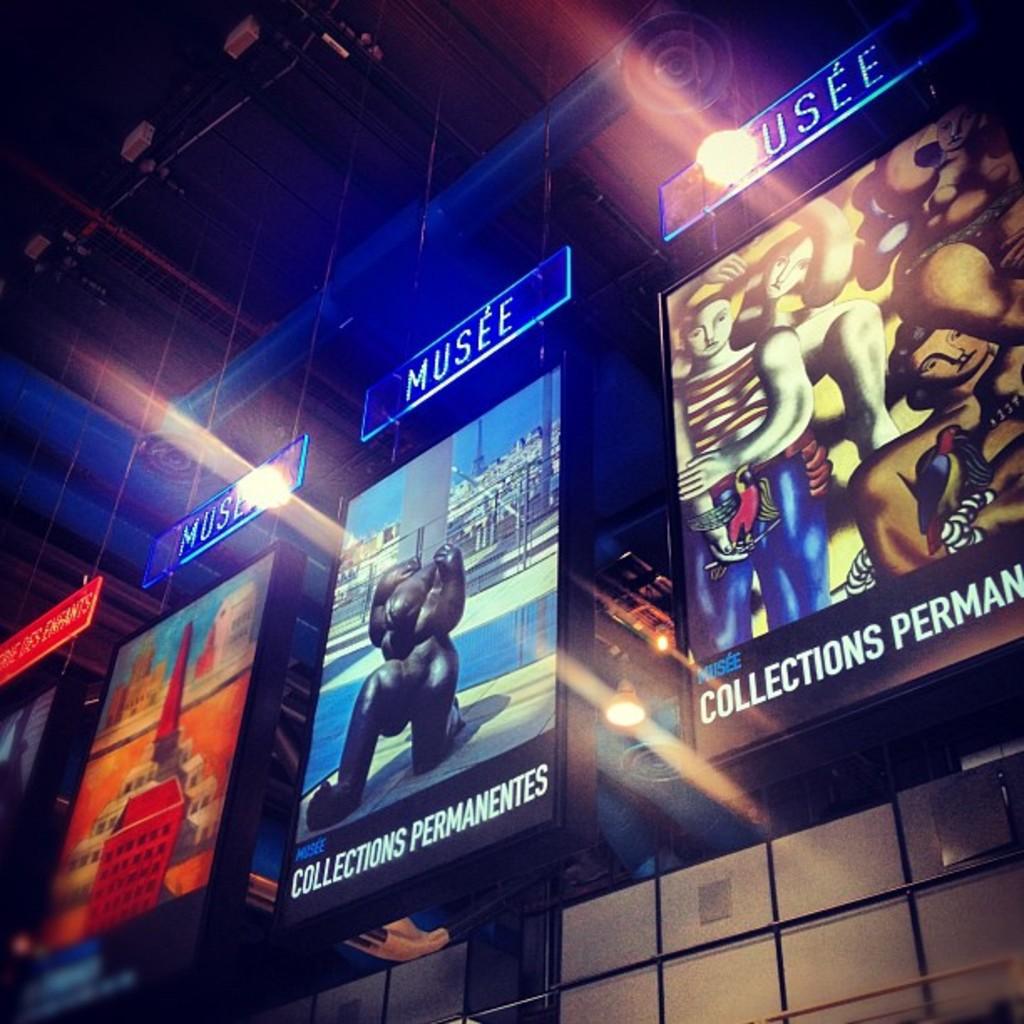What is written on the glowing blue signs?
Make the answer very short. Musee. 